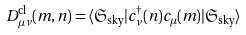Convert formula to latex. <formula><loc_0><loc_0><loc_500><loc_500>D _ { \mu \nu } ^ { \text {cl} } ( m , n ) = \langle \mathfrak { S } _ { \text {sky} } | c _ { \nu } ^ { \dag } ( n ) c _ { \mu } ( m ) | \mathfrak { S } _ { \text {sky} } \rangle</formula> 